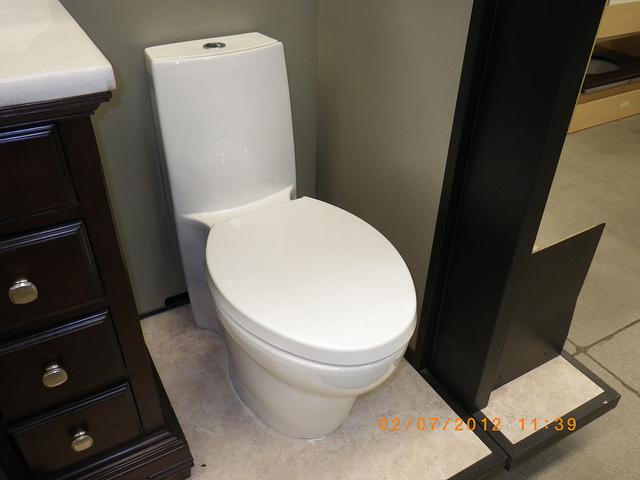What room is this?
Write a very short answer. Bathroom. What's the date on the picture?
Quick response, please. 02/07/2012. Which toilet is red?
Answer briefly. 0. How many drawers are there?
Write a very short answer. 4. Are the floor tiles even?
Be succinct. Yes. Where is the flush handle?
Answer briefly. Top. 